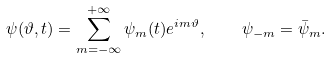<formula> <loc_0><loc_0><loc_500><loc_500>\psi ( \vartheta , t ) = \sum _ { m = - \infty } ^ { + \infty } \psi _ { m } ( t ) e ^ { i m \vartheta } , \quad \psi _ { - m } = \bar { \psi } _ { m } .</formula> 